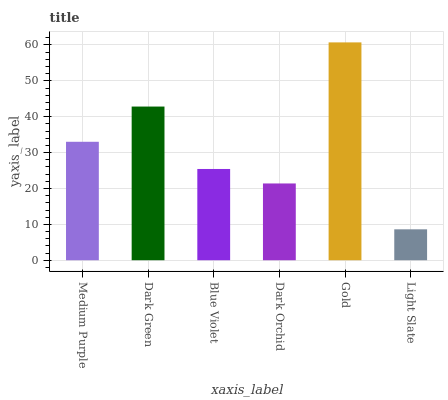Is Light Slate the minimum?
Answer yes or no. Yes. Is Gold the maximum?
Answer yes or no. Yes. Is Dark Green the minimum?
Answer yes or no. No. Is Dark Green the maximum?
Answer yes or no. No. Is Dark Green greater than Medium Purple?
Answer yes or no. Yes. Is Medium Purple less than Dark Green?
Answer yes or no. Yes. Is Medium Purple greater than Dark Green?
Answer yes or no. No. Is Dark Green less than Medium Purple?
Answer yes or no. No. Is Medium Purple the high median?
Answer yes or no. Yes. Is Blue Violet the low median?
Answer yes or no. Yes. Is Dark Green the high median?
Answer yes or no. No. Is Gold the low median?
Answer yes or no. No. 